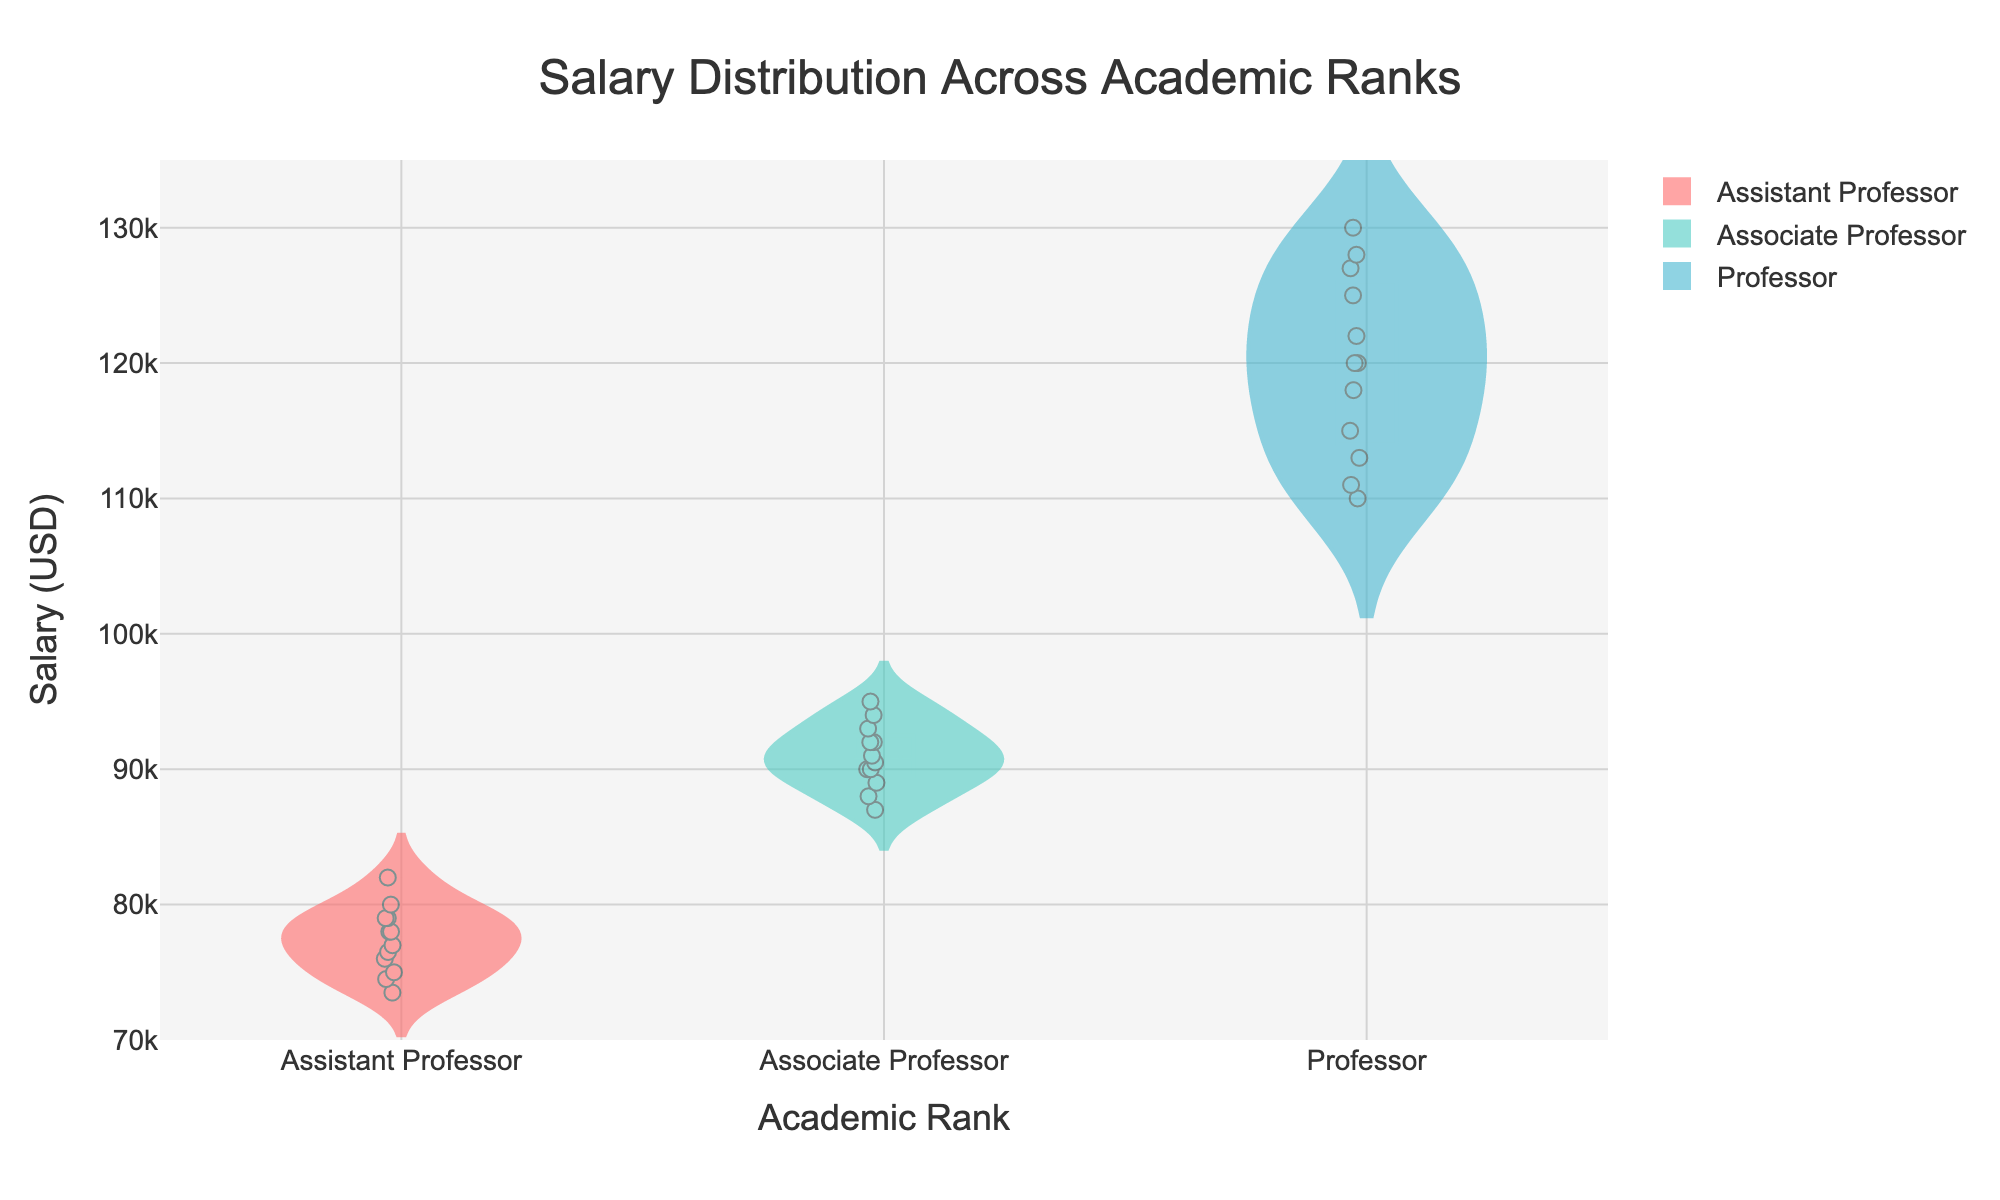What is the title of the figure? The title is located at the top center of the figure. It summarizes the purpose of the chart and the data being visualized.
Answer: Salary Distribution Across Academic Ranks How many academic ranks are being compared in the figure? There are distinct sections for each rank shown on the x-axis. Each section represents a different academic rank.
Answer: 3 What is the range of salaries represented in the figure? The y-axis shows the range of salaries, and the lower and upper bounds of the y-axis provide this range.
Answer: 70,000 to 135,000 USD Which academic rank has the widest salary distribution? By observing the spread of the violins, the rank with the widest spread from the bottom to the top of the violin represents the rank with the widest salary distribution.
Answer: Professor Which academic rank has the highest mean salary? Inside each violin, there's a horizontal line representing the mean salary for that rank. The rank with the highest positioned mean line has the highest mean salary.
Answer: Professor What is the median salary for Assistant Professors? The box visible within the violin for Assistant Professors includes a line in the middle representing the median salary.
Answer: 77,500 USD (approximately) Which university has the highest maximum salary for Professors? The highest point of the violin in the Professor section indicates the maximum salary. The data points within the violin can help determine the specific university.
Answer: Stanford University Do any academic ranks have overlapping salary ranges? By comparing the violins, one can see if the distribution of salaries for different ranks overlaps vertically.
Answer: Yes What is the interquartile range (IQR) for Associate Professors? The IQR is the range between the 25th percentile (bottom of the box) and the 75th percentile (top of the box) within the violin for Associate Professors.
Answer: 89,000 to 92,500 USD (approximately) Which academic rank has the smallest interquartile range? By comparing the boxes within each violin, the rank with the smallest vertical box length has the smallest IQR.
Answer: Professor 